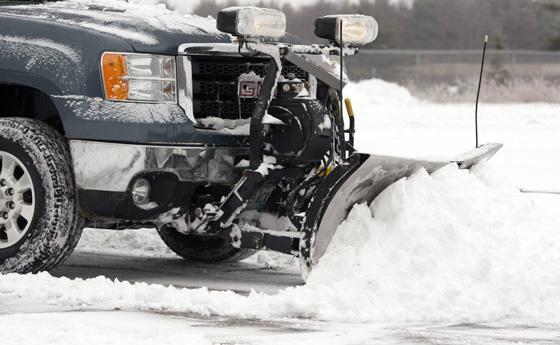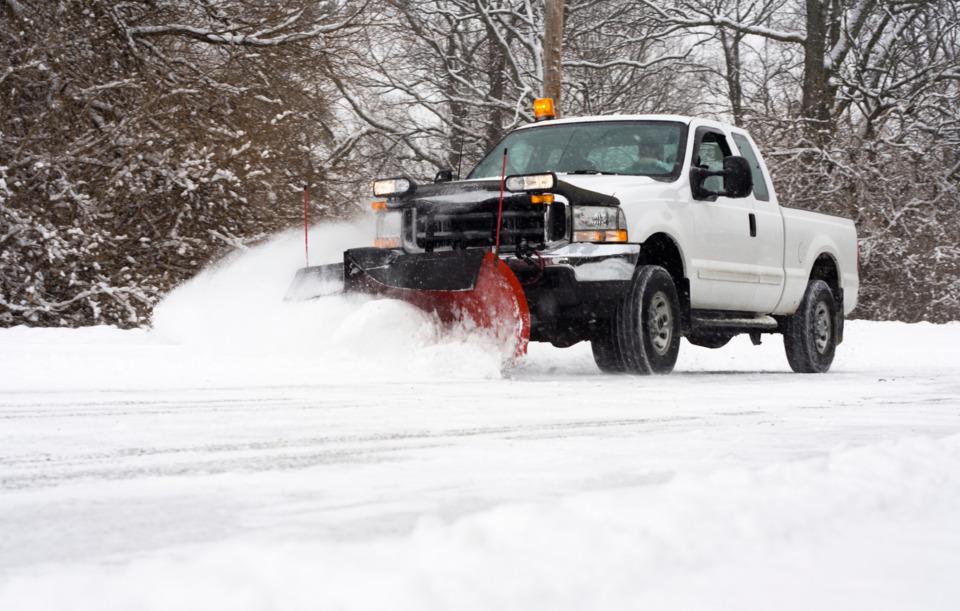The first image is the image on the left, the second image is the image on the right. For the images displayed, is the sentence "there is at least one red truck in the image" factually correct? Answer yes or no. No. 